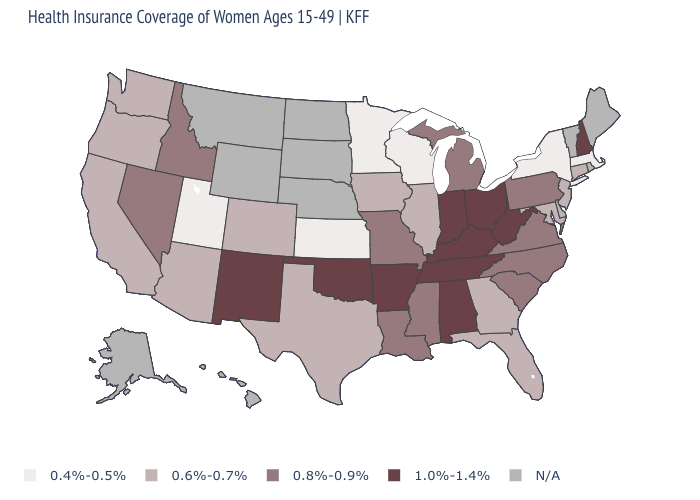Name the states that have a value in the range 0.8%-0.9%?
Short answer required. Idaho, Louisiana, Michigan, Mississippi, Missouri, Nevada, North Carolina, Pennsylvania, South Carolina, Virginia. What is the value of Maryland?
Quick response, please. 0.6%-0.7%. What is the value of Montana?
Be succinct. N/A. Among the states that border California , which have the highest value?
Concise answer only. Nevada. Does New Mexico have the highest value in the West?
Keep it brief. Yes. How many symbols are there in the legend?
Answer briefly. 5. What is the value of South Dakota?
Short answer required. N/A. Which states have the highest value in the USA?
Quick response, please. Alabama, Arkansas, Indiana, Kentucky, New Hampshire, New Mexico, Ohio, Oklahoma, Tennessee, West Virginia. Which states have the lowest value in the MidWest?
Answer briefly. Kansas, Minnesota, Wisconsin. What is the value of Arizona?
Quick response, please. 0.6%-0.7%. Does the map have missing data?
Write a very short answer. Yes. What is the highest value in the West ?
Write a very short answer. 1.0%-1.4%. What is the value of Colorado?
Keep it brief. 0.6%-0.7%. Name the states that have a value in the range 0.8%-0.9%?
Answer briefly. Idaho, Louisiana, Michigan, Mississippi, Missouri, Nevada, North Carolina, Pennsylvania, South Carolina, Virginia. 